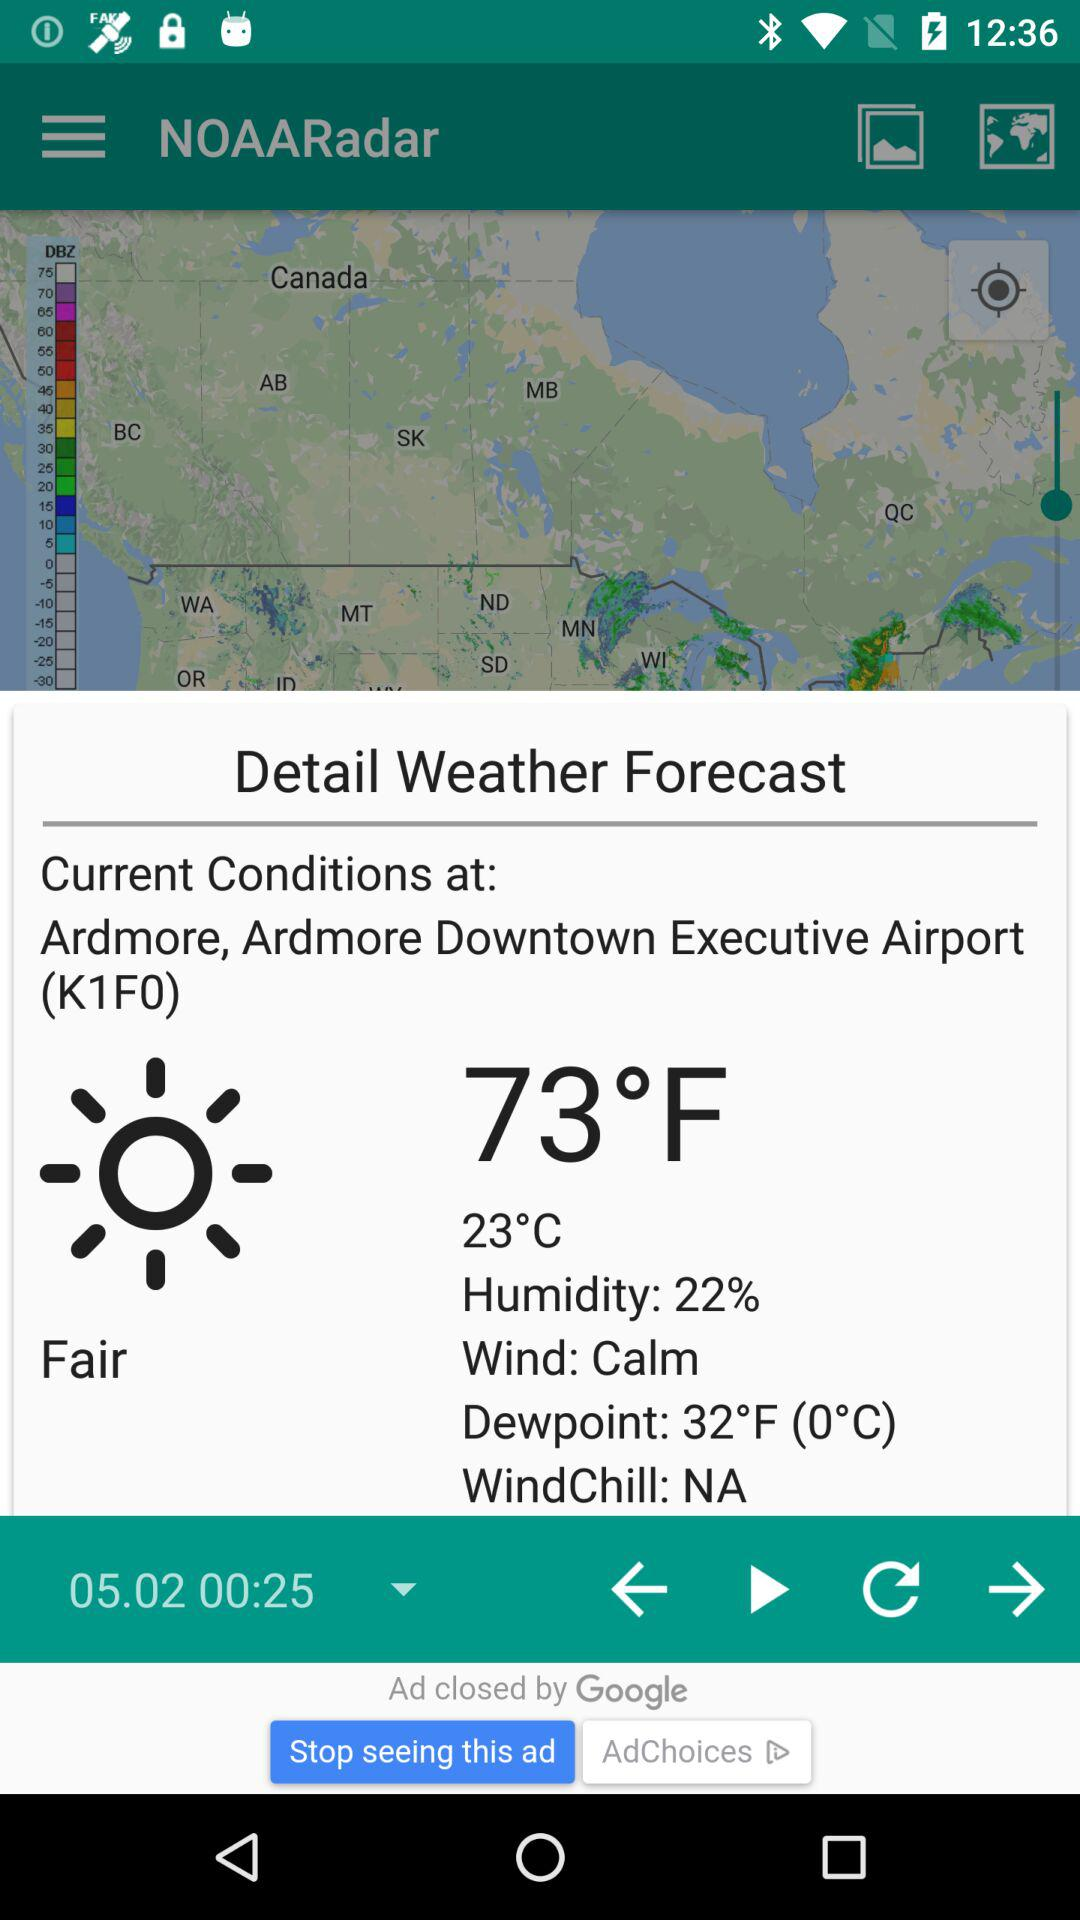What is the status of the downpoint?
When the provided information is insufficient, respond with <no answer>. <no answer> 